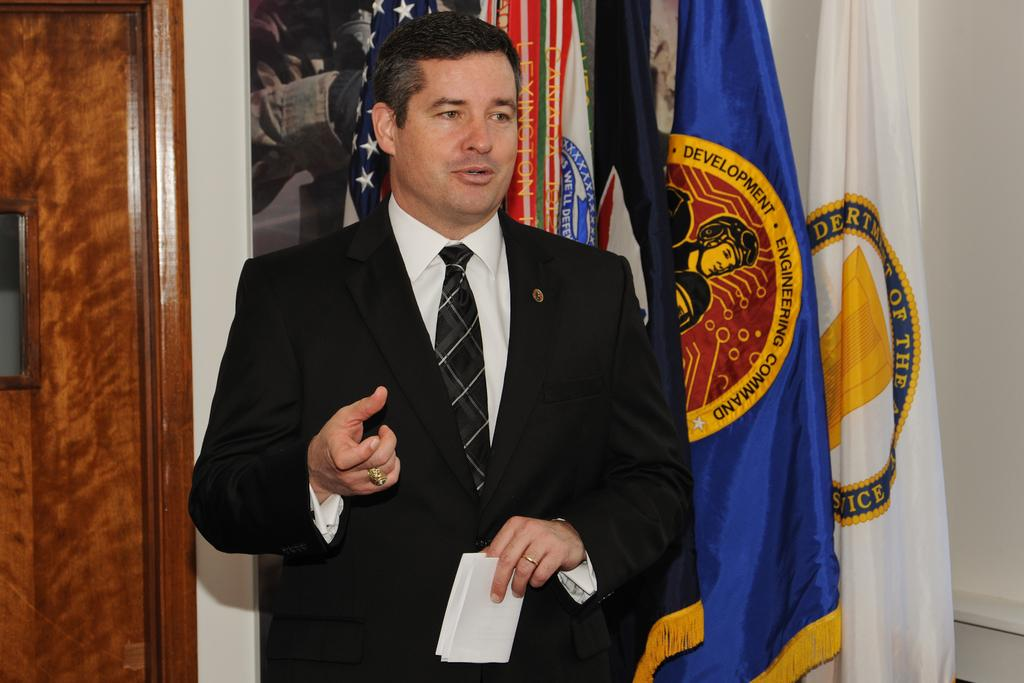<image>
Relay a brief, clear account of the picture shown. A man speaking in front of many flags one displaying engineering Command 